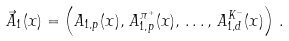<formula> <loc_0><loc_0><loc_500><loc_500>\vec { A } _ { 1 } ( x ) = \left ( A _ { 1 , p } ( x ) , \, A _ { 1 , p } ^ { \pi ^ { + } } ( x ) , \, \dots , \, A _ { 1 , d } ^ { K ^ { - } } ( x ) \right ) \, .</formula> 